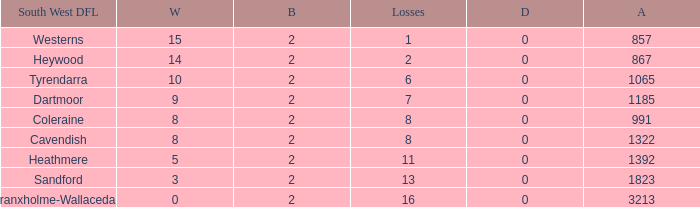Which Losses have a South West DFL of branxholme-wallacedale, and less than 2 Byes? None. 